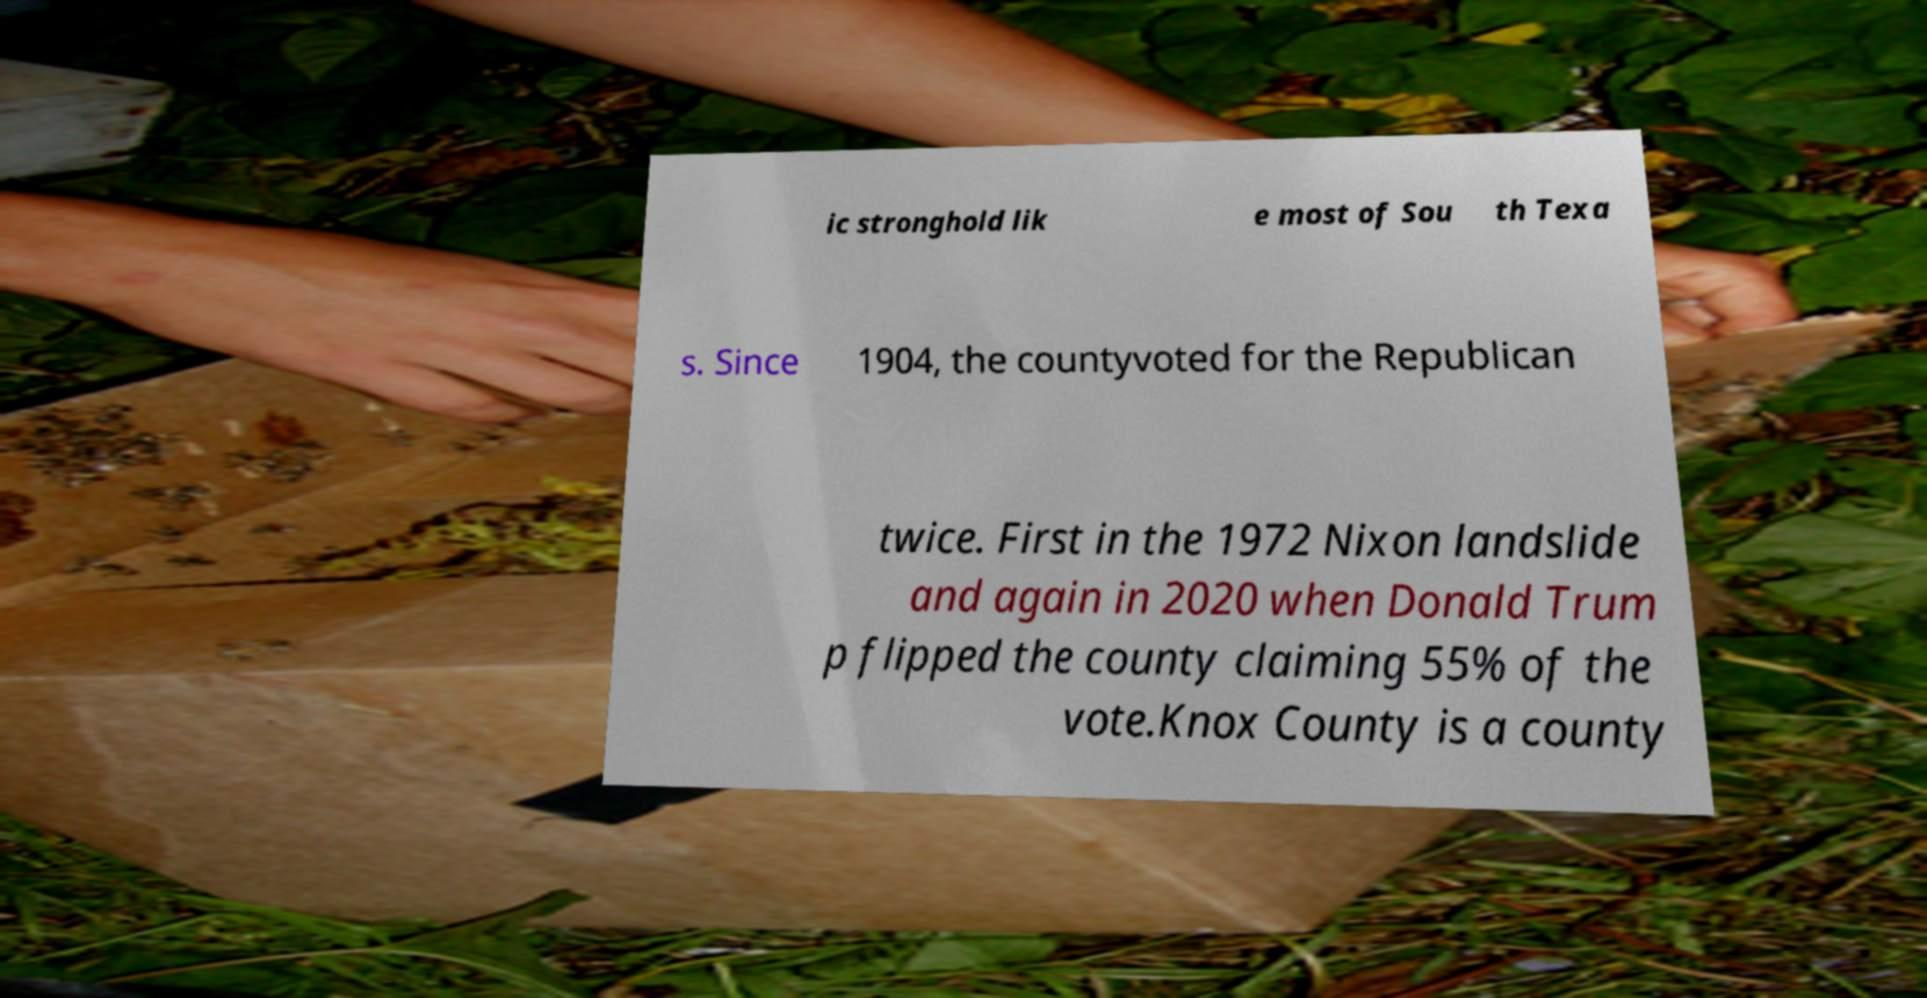I need the written content from this picture converted into text. Can you do that? ic stronghold lik e most of Sou th Texa s. Since 1904, the countyvoted for the Republican twice. First in the 1972 Nixon landslide and again in 2020 when Donald Trum p flipped the county claiming 55% of the vote.Knox County is a county 